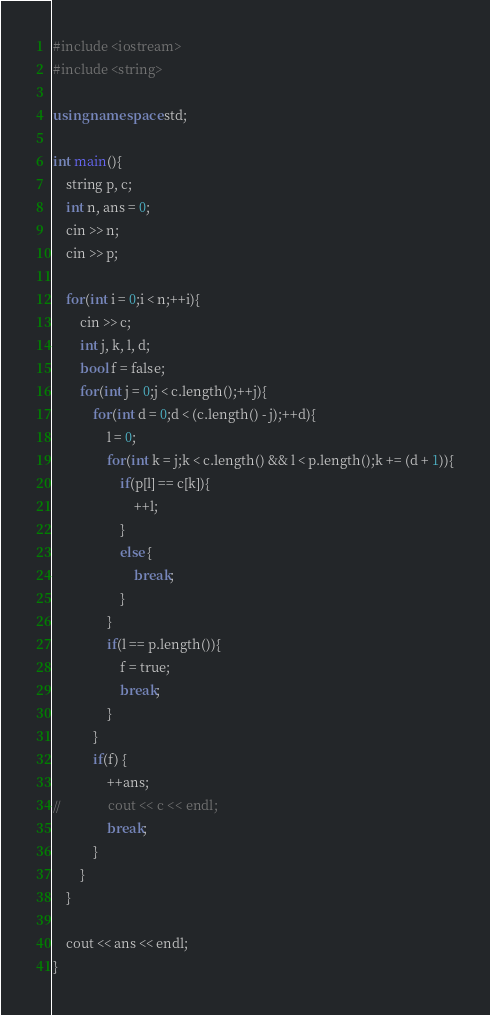<code> <loc_0><loc_0><loc_500><loc_500><_C++_>#include <iostream>
#include <string>

using namespace std;

int main(){
	string p, c;
	int n, ans = 0;
	cin >> n;
	cin >> p;

	for(int i = 0;i < n;++i){
		cin >> c;
		int j, k, l, d;
		bool f = false;
		for(int j = 0;j < c.length();++j){
			for(int d = 0;d < (c.length() - j);++d){
				l = 0;
				for(int k = j;k < c.length() && l < p.length();k += (d + 1)){
					if(p[l] == c[k]){
						++l;
					}
					else {
						break;
					}
				}
				if(l == p.length()){
					f = true;
					break;
				}
			}
			if(f) {
				++ans;
//				cout << c << endl;
				break;
			}
		}
	}

	cout << ans << endl;
}</code> 